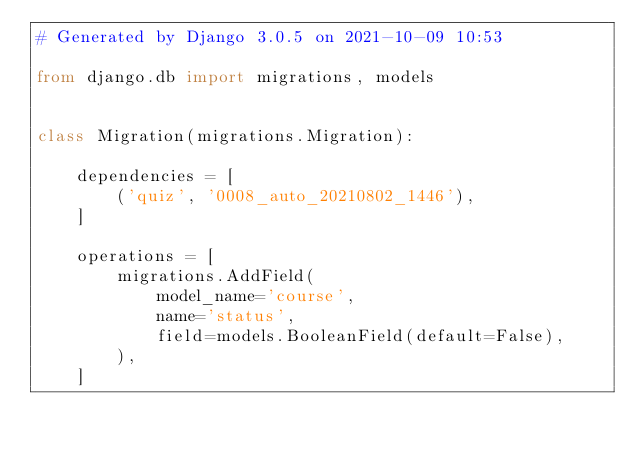<code> <loc_0><loc_0><loc_500><loc_500><_Python_># Generated by Django 3.0.5 on 2021-10-09 10:53

from django.db import migrations, models


class Migration(migrations.Migration):

    dependencies = [
        ('quiz', '0008_auto_20210802_1446'),
    ]

    operations = [
        migrations.AddField(
            model_name='course',
            name='status',
            field=models.BooleanField(default=False),
        ),
    ]
</code> 